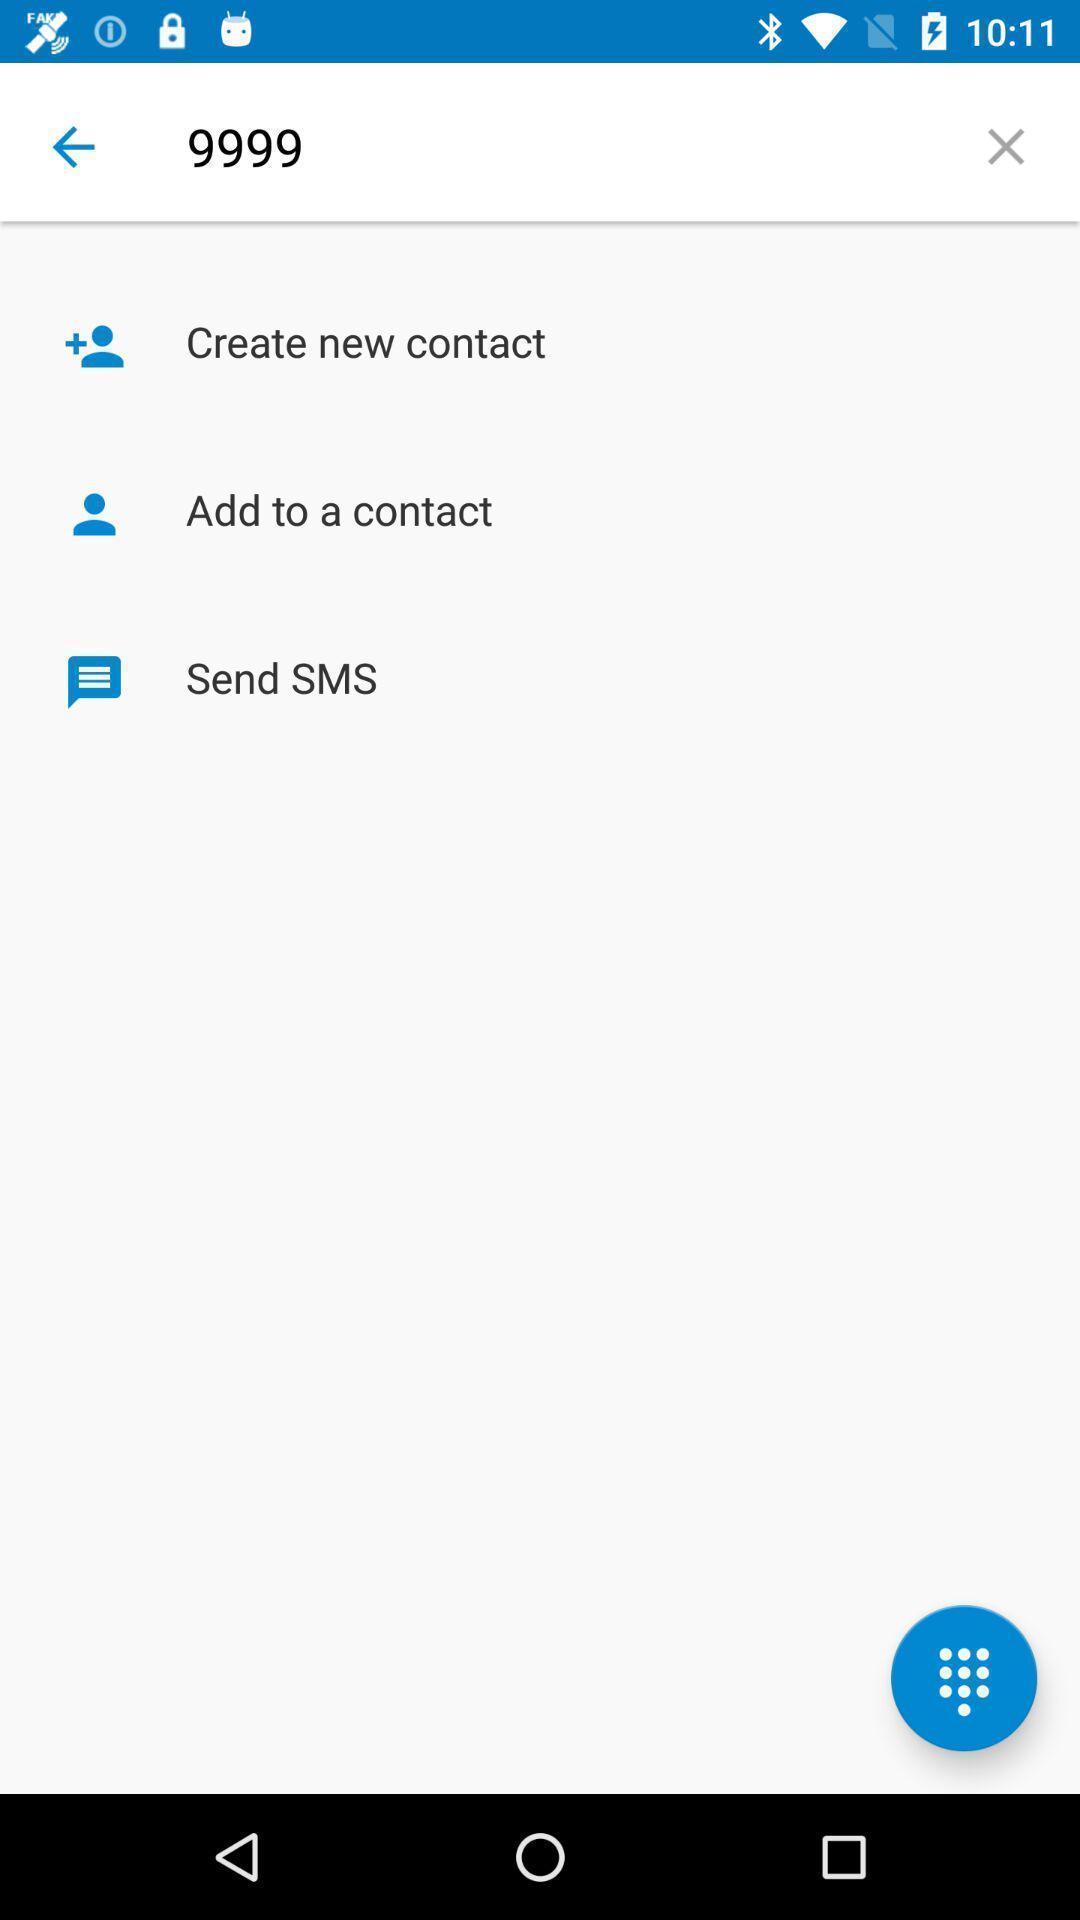Describe the key features of this screenshot. Various options available in the app. 